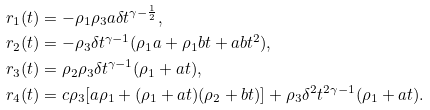Convert formula to latex. <formula><loc_0><loc_0><loc_500><loc_500>r _ { 1 } ( t ) & = - \rho _ { 1 } \rho _ { 3 } a \delta t ^ { \gamma - \frac { 1 } { 2 } } , \\ r _ { 2 } ( t ) & = - \rho _ { 3 } \delta t ^ { \gamma - 1 } ( \rho _ { 1 } a + \rho _ { 1 } b t + a b t ^ { 2 } ) , \\ r _ { 3 } ( t ) & = \rho _ { 2 } \rho _ { 3 } \delta t ^ { \gamma - 1 } ( \rho _ { 1 } + a t ) , \\ r _ { 4 } ( t ) & = c \rho _ { 3 } [ a \rho _ { 1 } + ( \rho _ { 1 } + a t ) ( \rho _ { 2 } + b t ) ] + \rho _ { 3 } \delta ^ { 2 } t ^ { 2 \gamma - 1 } ( \rho _ { 1 } + a t ) .</formula> 